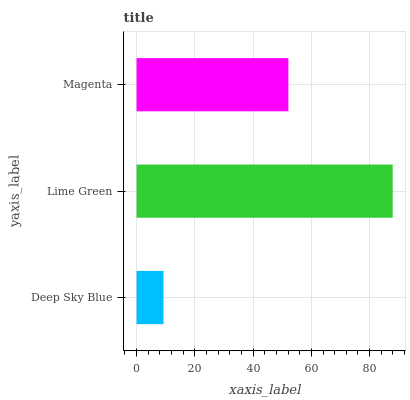Is Deep Sky Blue the minimum?
Answer yes or no. Yes. Is Lime Green the maximum?
Answer yes or no. Yes. Is Magenta the minimum?
Answer yes or no. No. Is Magenta the maximum?
Answer yes or no. No. Is Lime Green greater than Magenta?
Answer yes or no. Yes. Is Magenta less than Lime Green?
Answer yes or no. Yes. Is Magenta greater than Lime Green?
Answer yes or no. No. Is Lime Green less than Magenta?
Answer yes or no. No. Is Magenta the high median?
Answer yes or no. Yes. Is Magenta the low median?
Answer yes or no. Yes. Is Deep Sky Blue the high median?
Answer yes or no. No. Is Lime Green the low median?
Answer yes or no. No. 